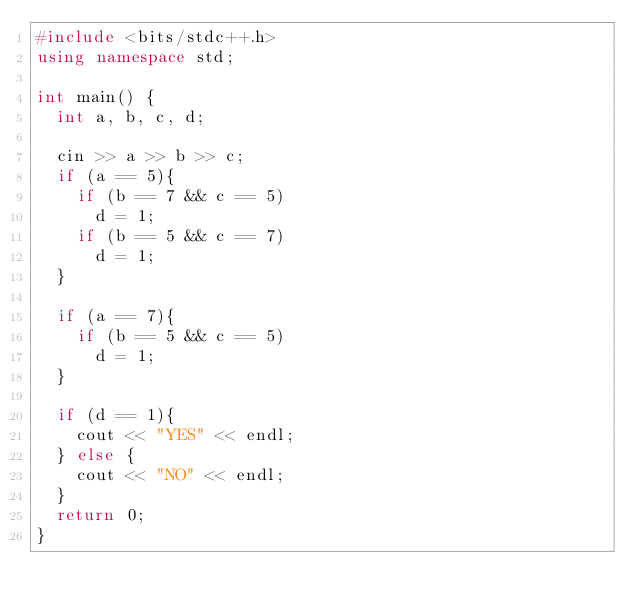<code> <loc_0><loc_0><loc_500><loc_500><_C++_>#include <bits/stdc++.h>
using namespace std;

int main() {
  int a, b, c, d;
  
  cin >> a >> b >> c;
  if (a == 5){
    if (b == 7 && c == 5)
      d = 1;
    if (b == 5 && c == 7)
      d = 1;
  }
  
  if (a == 7){
    if (b == 5 && c == 5)
      d = 1;
  }
    
  if (d == 1){
    cout << "YES" << endl;
  } else {
    cout << "NO" << endl;
  }
  return 0;
}</code> 